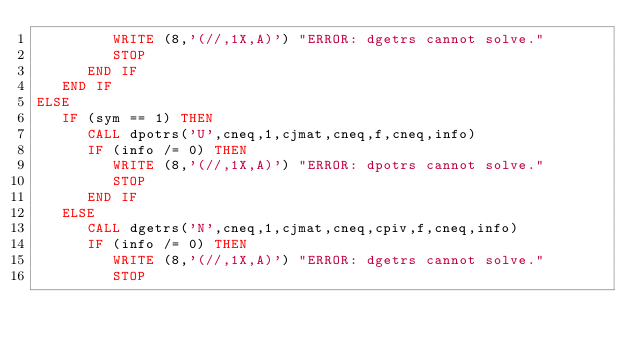<code> <loc_0><loc_0><loc_500><loc_500><_FORTRAN_>         WRITE (8,'(//,1X,A)') "ERROR: dgetrs cannot solve."
         STOP
      END IF
   END IF
ELSE
   IF (sym == 1) THEN
      CALL dpotrs('U',cneq,1,cjmat,cneq,f,cneq,info)
      IF (info /= 0) THEN
         WRITE (8,'(//,1X,A)') "ERROR: dpotrs cannot solve."
         STOP
      END IF
   ELSE
      CALL dgetrs('N',cneq,1,cjmat,cneq,cpiv,f,cneq,info)
      IF (info /= 0) THEN
         WRITE (8,'(//,1X,A)') "ERROR: dgetrs cannot solve."
         STOP</code> 